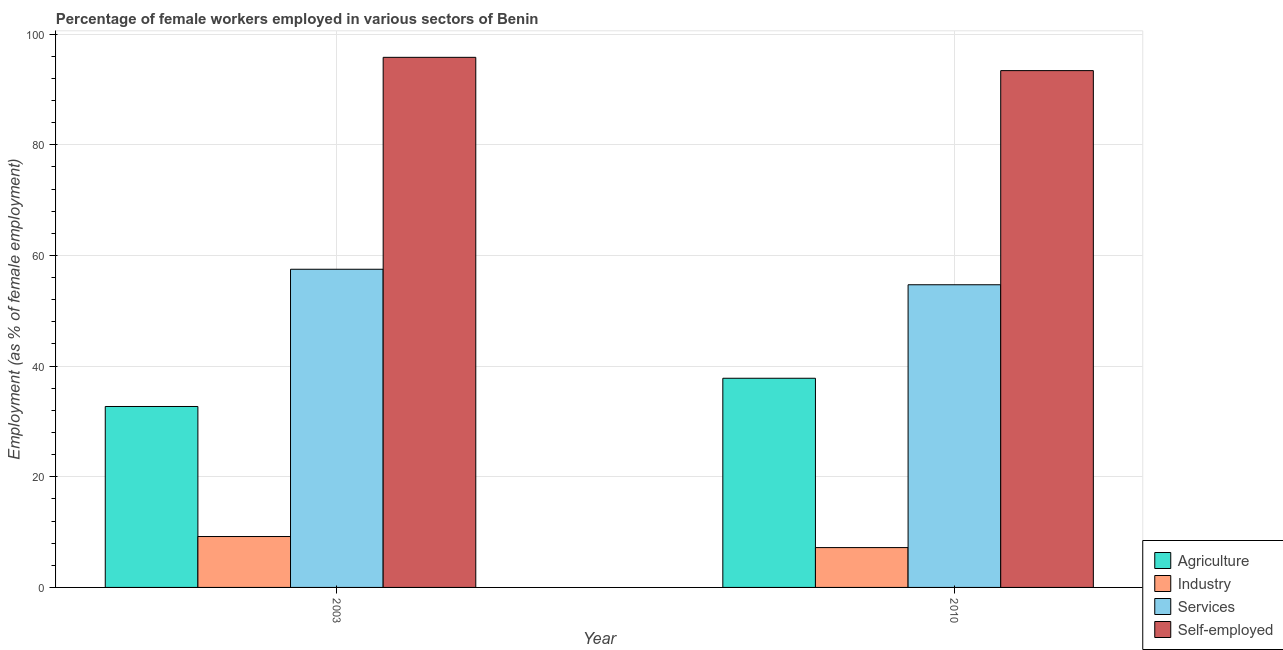How many different coloured bars are there?
Your answer should be very brief. 4. Are the number of bars on each tick of the X-axis equal?
Ensure brevity in your answer.  Yes. How many bars are there on the 1st tick from the right?
Make the answer very short. 4. What is the percentage of female workers in services in 2010?
Your answer should be compact. 54.7. Across all years, what is the maximum percentage of female workers in industry?
Provide a succinct answer. 9.2. Across all years, what is the minimum percentage of female workers in agriculture?
Provide a succinct answer. 32.7. In which year was the percentage of female workers in services maximum?
Provide a short and direct response. 2003. What is the total percentage of female workers in services in the graph?
Your answer should be compact. 112.2. What is the difference between the percentage of female workers in agriculture in 2003 and that in 2010?
Keep it short and to the point. -5.1. What is the difference between the percentage of female workers in services in 2010 and the percentage of female workers in industry in 2003?
Provide a succinct answer. -2.8. What is the average percentage of self employed female workers per year?
Provide a succinct answer. 94.6. In how many years, is the percentage of female workers in agriculture greater than 72 %?
Offer a very short reply. 0. What is the ratio of the percentage of female workers in industry in 2003 to that in 2010?
Your response must be concise. 1.28. Is the percentage of self employed female workers in 2003 less than that in 2010?
Give a very brief answer. No. What does the 4th bar from the left in 2010 represents?
Your answer should be compact. Self-employed. What does the 1st bar from the right in 2003 represents?
Make the answer very short. Self-employed. Is it the case that in every year, the sum of the percentage of female workers in agriculture and percentage of female workers in industry is greater than the percentage of female workers in services?
Make the answer very short. No. Are all the bars in the graph horizontal?
Keep it short and to the point. No. How many years are there in the graph?
Make the answer very short. 2. Are the values on the major ticks of Y-axis written in scientific E-notation?
Offer a very short reply. No. Does the graph contain grids?
Your answer should be very brief. Yes. How many legend labels are there?
Give a very brief answer. 4. What is the title of the graph?
Provide a succinct answer. Percentage of female workers employed in various sectors of Benin. What is the label or title of the X-axis?
Provide a short and direct response. Year. What is the label or title of the Y-axis?
Keep it short and to the point. Employment (as % of female employment). What is the Employment (as % of female employment) of Agriculture in 2003?
Give a very brief answer. 32.7. What is the Employment (as % of female employment) in Industry in 2003?
Keep it short and to the point. 9.2. What is the Employment (as % of female employment) in Services in 2003?
Provide a succinct answer. 57.5. What is the Employment (as % of female employment) of Self-employed in 2003?
Your answer should be very brief. 95.8. What is the Employment (as % of female employment) of Agriculture in 2010?
Provide a succinct answer. 37.8. What is the Employment (as % of female employment) of Industry in 2010?
Provide a short and direct response. 7.2. What is the Employment (as % of female employment) of Services in 2010?
Your response must be concise. 54.7. What is the Employment (as % of female employment) of Self-employed in 2010?
Ensure brevity in your answer.  93.4. Across all years, what is the maximum Employment (as % of female employment) of Agriculture?
Your answer should be compact. 37.8. Across all years, what is the maximum Employment (as % of female employment) in Industry?
Your response must be concise. 9.2. Across all years, what is the maximum Employment (as % of female employment) in Services?
Offer a terse response. 57.5. Across all years, what is the maximum Employment (as % of female employment) of Self-employed?
Your answer should be compact. 95.8. Across all years, what is the minimum Employment (as % of female employment) in Agriculture?
Your answer should be very brief. 32.7. Across all years, what is the minimum Employment (as % of female employment) of Industry?
Your answer should be very brief. 7.2. Across all years, what is the minimum Employment (as % of female employment) in Services?
Your response must be concise. 54.7. Across all years, what is the minimum Employment (as % of female employment) of Self-employed?
Keep it short and to the point. 93.4. What is the total Employment (as % of female employment) in Agriculture in the graph?
Make the answer very short. 70.5. What is the total Employment (as % of female employment) of Services in the graph?
Offer a very short reply. 112.2. What is the total Employment (as % of female employment) in Self-employed in the graph?
Ensure brevity in your answer.  189.2. What is the difference between the Employment (as % of female employment) of Services in 2003 and that in 2010?
Provide a succinct answer. 2.8. What is the difference between the Employment (as % of female employment) of Agriculture in 2003 and the Employment (as % of female employment) of Industry in 2010?
Provide a succinct answer. 25.5. What is the difference between the Employment (as % of female employment) in Agriculture in 2003 and the Employment (as % of female employment) in Services in 2010?
Your answer should be compact. -22. What is the difference between the Employment (as % of female employment) in Agriculture in 2003 and the Employment (as % of female employment) in Self-employed in 2010?
Keep it short and to the point. -60.7. What is the difference between the Employment (as % of female employment) in Industry in 2003 and the Employment (as % of female employment) in Services in 2010?
Ensure brevity in your answer.  -45.5. What is the difference between the Employment (as % of female employment) in Industry in 2003 and the Employment (as % of female employment) in Self-employed in 2010?
Keep it short and to the point. -84.2. What is the difference between the Employment (as % of female employment) of Services in 2003 and the Employment (as % of female employment) of Self-employed in 2010?
Your answer should be very brief. -35.9. What is the average Employment (as % of female employment) in Agriculture per year?
Give a very brief answer. 35.25. What is the average Employment (as % of female employment) in Industry per year?
Your answer should be very brief. 8.2. What is the average Employment (as % of female employment) of Services per year?
Your answer should be compact. 56.1. What is the average Employment (as % of female employment) of Self-employed per year?
Offer a terse response. 94.6. In the year 2003, what is the difference between the Employment (as % of female employment) in Agriculture and Employment (as % of female employment) in Industry?
Keep it short and to the point. 23.5. In the year 2003, what is the difference between the Employment (as % of female employment) in Agriculture and Employment (as % of female employment) in Services?
Provide a short and direct response. -24.8. In the year 2003, what is the difference between the Employment (as % of female employment) in Agriculture and Employment (as % of female employment) in Self-employed?
Offer a very short reply. -63.1. In the year 2003, what is the difference between the Employment (as % of female employment) in Industry and Employment (as % of female employment) in Services?
Make the answer very short. -48.3. In the year 2003, what is the difference between the Employment (as % of female employment) in Industry and Employment (as % of female employment) in Self-employed?
Offer a terse response. -86.6. In the year 2003, what is the difference between the Employment (as % of female employment) of Services and Employment (as % of female employment) of Self-employed?
Your answer should be very brief. -38.3. In the year 2010, what is the difference between the Employment (as % of female employment) in Agriculture and Employment (as % of female employment) in Industry?
Keep it short and to the point. 30.6. In the year 2010, what is the difference between the Employment (as % of female employment) of Agriculture and Employment (as % of female employment) of Services?
Provide a succinct answer. -16.9. In the year 2010, what is the difference between the Employment (as % of female employment) of Agriculture and Employment (as % of female employment) of Self-employed?
Make the answer very short. -55.6. In the year 2010, what is the difference between the Employment (as % of female employment) of Industry and Employment (as % of female employment) of Services?
Offer a very short reply. -47.5. In the year 2010, what is the difference between the Employment (as % of female employment) of Industry and Employment (as % of female employment) of Self-employed?
Provide a short and direct response. -86.2. In the year 2010, what is the difference between the Employment (as % of female employment) in Services and Employment (as % of female employment) in Self-employed?
Make the answer very short. -38.7. What is the ratio of the Employment (as % of female employment) in Agriculture in 2003 to that in 2010?
Make the answer very short. 0.87. What is the ratio of the Employment (as % of female employment) in Industry in 2003 to that in 2010?
Offer a very short reply. 1.28. What is the ratio of the Employment (as % of female employment) in Services in 2003 to that in 2010?
Provide a succinct answer. 1.05. What is the ratio of the Employment (as % of female employment) in Self-employed in 2003 to that in 2010?
Your answer should be very brief. 1.03. What is the difference between the highest and the lowest Employment (as % of female employment) of Agriculture?
Ensure brevity in your answer.  5.1. What is the difference between the highest and the lowest Employment (as % of female employment) in Industry?
Your answer should be compact. 2. What is the difference between the highest and the lowest Employment (as % of female employment) of Services?
Make the answer very short. 2.8. What is the difference between the highest and the lowest Employment (as % of female employment) in Self-employed?
Your answer should be very brief. 2.4. 